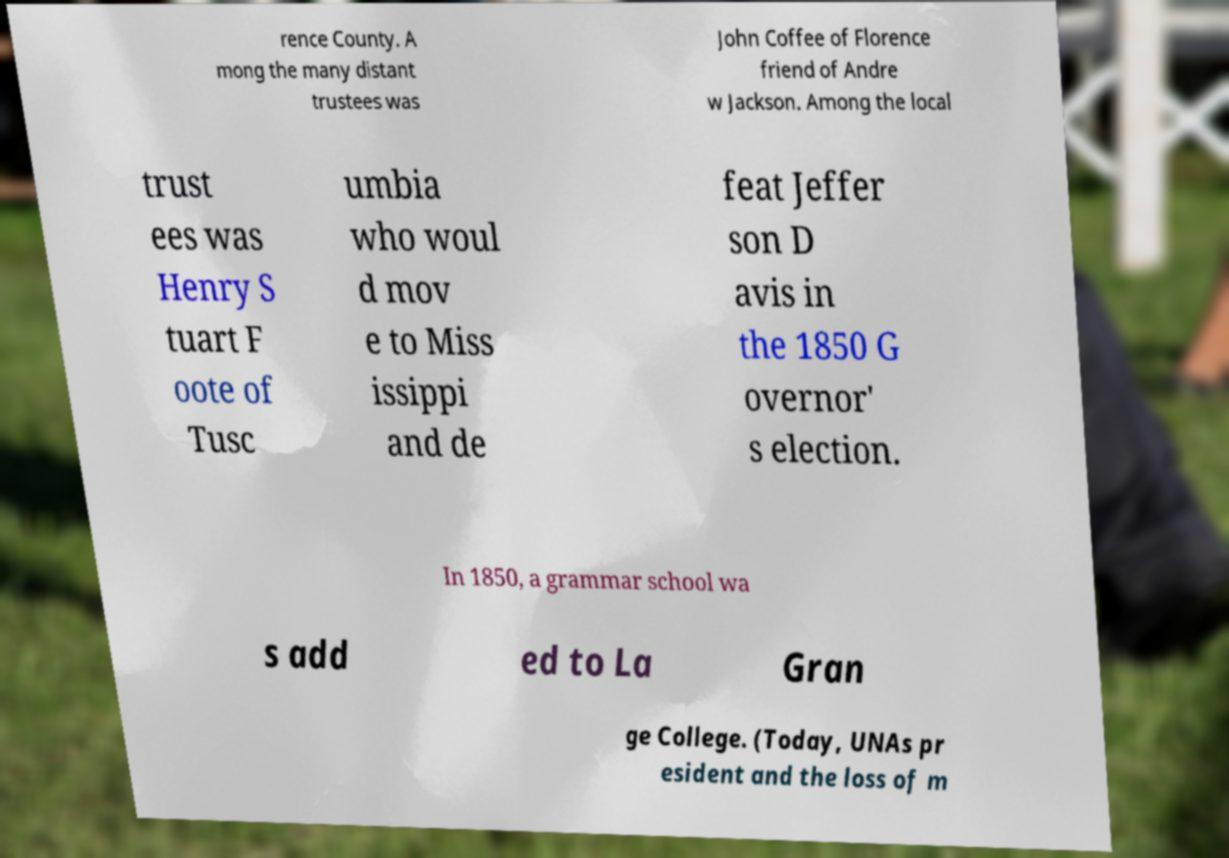Please read and relay the text visible in this image. What does it say? rence County. A mong the many distant trustees was John Coffee of Florence friend of Andre w Jackson. Among the local trust ees was Henry S tuart F oote of Tusc umbia who woul d mov e to Miss issippi and de feat Jeffer son D avis in the 1850 G overnor' s election. In 1850, a grammar school wa s add ed to La Gran ge College. (Today, UNAs pr esident and the loss of m 